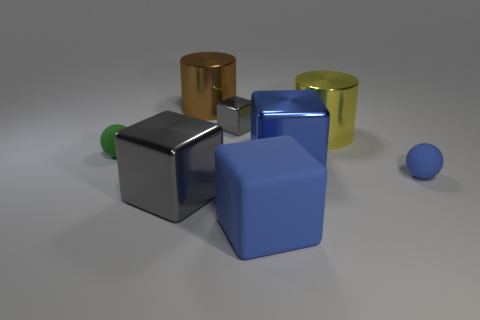Subtract 1 cubes. How many cubes are left? 3 Add 2 big gray shiny balls. How many objects exist? 10 Subtract all cylinders. How many objects are left? 6 Add 5 brown things. How many brown things exist? 6 Subtract 0 green cylinders. How many objects are left? 8 Subtract all small gray shiny blocks. Subtract all tiny purple rubber balls. How many objects are left? 7 Add 4 small blue things. How many small blue things are left? 5 